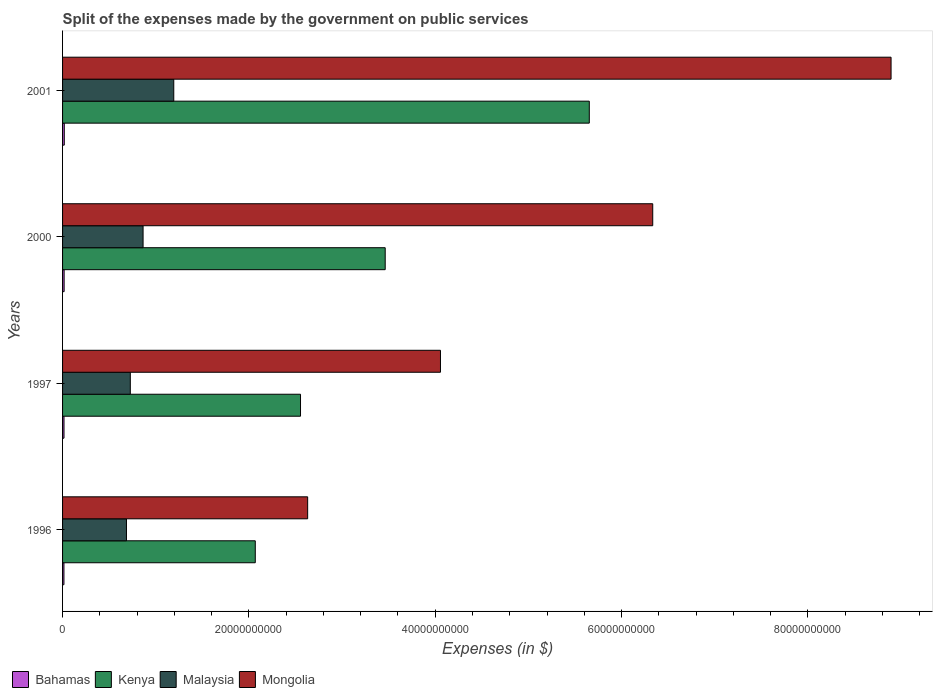How many different coloured bars are there?
Offer a terse response. 4. How many groups of bars are there?
Ensure brevity in your answer.  4. Are the number of bars per tick equal to the number of legend labels?
Your response must be concise. Yes. How many bars are there on the 3rd tick from the bottom?
Your response must be concise. 4. In how many cases, is the number of bars for a given year not equal to the number of legend labels?
Offer a very short reply. 0. What is the expenses made by the government on public services in Mongolia in 1997?
Provide a succinct answer. 4.06e+1. Across all years, what is the maximum expenses made by the government on public services in Bahamas?
Offer a terse response. 1.85e+08. Across all years, what is the minimum expenses made by the government on public services in Bahamas?
Your response must be concise. 1.47e+08. In which year was the expenses made by the government on public services in Bahamas maximum?
Keep it short and to the point. 2001. In which year was the expenses made by the government on public services in Mongolia minimum?
Provide a succinct answer. 1996. What is the total expenses made by the government on public services in Kenya in the graph?
Offer a terse response. 1.37e+11. What is the difference between the expenses made by the government on public services in Kenya in 1996 and that in 2001?
Provide a succinct answer. -3.59e+1. What is the difference between the expenses made by the government on public services in Kenya in 2000 and the expenses made by the government on public services in Mongolia in 1997?
Your answer should be very brief. -5.93e+09. What is the average expenses made by the government on public services in Bahamas per year?
Provide a short and direct response. 1.63e+08. In the year 2001, what is the difference between the expenses made by the government on public services in Bahamas and expenses made by the government on public services in Mongolia?
Provide a short and direct response. -8.87e+1. In how many years, is the expenses made by the government on public services in Malaysia greater than 84000000000 $?
Offer a very short reply. 0. What is the ratio of the expenses made by the government on public services in Malaysia in 1997 to that in 2000?
Provide a short and direct response. 0.84. Is the difference between the expenses made by the government on public services in Bahamas in 1997 and 2000 greater than the difference between the expenses made by the government on public services in Mongolia in 1997 and 2000?
Keep it short and to the point. Yes. What is the difference between the highest and the second highest expenses made by the government on public services in Mongolia?
Give a very brief answer. 2.56e+1. What is the difference between the highest and the lowest expenses made by the government on public services in Mongolia?
Give a very brief answer. 6.26e+1. Is the sum of the expenses made by the government on public services in Bahamas in 2000 and 2001 greater than the maximum expenses made by the government on public services in Malaysia across all years?
Your response must be concise. No. What does the 2nd bar from the top in 2001 represents?
Give a very brief answer. Malaysia. What does the 2nd bar from the bottom in 2000 represents?
Provide a short and direct response. Kenya. Are all the bars in the graph horizontal?
Your response must be concise. Yes. How many years are there in the graph?
Your answer should be very brief. 4. What is the difference between two consecutive major ticks on the X-axis?
Provide a succinct answer. 2.00e+1. Does the graph contain grids?
Make the answer very short. No. How are the legend labels stacked?
Offer a very short reply. Horizontal. What is the title of the graph?
Keep it short and to the point. Split of the expenses made by the government on public services. Does "Malawi" appear as one of the legend labels in the graph?
Your answer should be compact. No. What is the label or title of the X-axis?
Make the answer very short. Expenses (in $). What is the Expenses (in $) of Bahamas in 1996?
Your response must be concise. 1.47e+08. What is the Expenses (in $) in Kenya in 1996?
Your answer should be very brief. 2.07e+1. What is the Expenses (in $) in Malaysia in 1996?
Offer a terse response. 6.86e+09. What is the Expenses (in $) of Mongolia in 1996?
Ensure brevity in your answer.  2.63e+1. What is the Expenses (in $) of Bahamas in 1997?
Give a very brief answer. 1.54e+08. What is the Expenses (in $) of Kenya in 1997?
Make the answer very short. 2.55e+1. What is the Expenses (in $) of Malaysia in 1997?
Your response must be concise. 7.27e+09. What is the Expenses (in $) in Mongolia in 1997?
Your answer should be very brief. 4.06e+1. What is the Expenses (in $) of Bahamas in 2000?
Give a very brief answer. 1.68e+08. What is the Expenses (in $) in Kenya in 2000?
Make the answer very short. 3.46e+1. What is the Expenses (in $) in Malaysia in 2000?
Your answer should be very brief. 8.64e+09. What is the Expenses (in $) in Mongolia in 2000?
Keep it short and to the point. 6.34e+1. What is the Expenses (in $) of Bahamas in 2001?
Offer a very short reply. 1.85e+08. What is the Expenses (in $) in Kenya in 2001?
Your answer should be very brief. 5.65e+1. What is the Expenses (in $) of Malaysia in 2001?
Provide a short and direct response. 1.19e+1. What is the Expenses (in $) of Mongolia in 2001?
Provide a short and direct response. 8.89e+1. Across all years, what is the maximum Expenses (in $) of Bahamas?
Your answer should be very brief. 1.85e+08. Across all years, what is the maximum Expenses (in $) of Kenya?
Ensure brevity in your answer.  5.65e+1. Across all years, what is the maximum Expenses (in $) in Malaysia?
Your answer should be very brief. 1.19e+1. Across all years, what is the maximum Expenses (in $) in Mongolia?
Your answer should be very brief. 8.89e+1. Across all years, what is the minimum Expenses (in $) in Bahamas?
Offer a very short reply. 1.47e+08. Across all years, what is the minimum Expenses (in $) of Kenya?
Offer a terse response. 2.07e+1. Across all years, what is the minimum Expenses (in $) of Malaysia?
Keep it short and to the point. 6.86e+09. Across all years, what is the minimum Expenses (in $) of Mongolia?
Give a very brief answer. 2.63e+1. What is the total Expenses (in $) in Bahamas in the graph?
Keep it short and to the point. 6.54e+08. What is the total Expenses (in $) in Kenya in the graph?
Your answer should be compact. 1.37e+11. What is the total Expenses (in $) of Malaysia in the graph?
Offer a terse response. 3.47e+1. What is the total Expenses (in $) of Mongolia in the graph?
Ensure brevity in your answer.  2.19e+11. What is the difference between the Expenses (in $) of Bahamas in 1996 and that in 1997?
Offer a very short reply. -7.70e+06. What is the difference between the Expenses (in $) in Kenya in 1996 and that in 1997?
Give a very brief answer. -4.86e+09. What is the difference between the Expenses (in $) of Malaysia in 1996 and that in 1997?
Provide a succinct answer. -4.12e+08. What is the difference between the Expenses (in $) in Mongolia in 1996 and that in 1997?
Offer a very short reply. -1.43e+1. What is the difference between the Expenses (in $) of Bahamas in 1996 and that in 2000?
Provide a short and direct response. -2.09e+07. What is the difference between the Expenses (in $) in Kenya in 1996 and that in 2000?
Provide a short and direct response. -1.39e+1. What is the difference between the Expenses (in $) of Malaysia in 1996 and that in 2000?
Your answer should be very brief. -1.78e+09. What is the difference between the Expenses (in $) in Mongolia in 1996 and that in 2000?
Make the answer very short. -3.70e+1. What is the difference between the Expenses (in $) in Bahamas in 1996 and that in 2001?
Offer a terse response. -3.81e+07. What is the difference between the Expenses (in $) of Kenya in 1996 and that in 2001?
Offer a terse response. -3.59e+1. What is the difference between the Expenses (in $) of Malaysia in 1996 and that in 2001?
Provide a short and direct response. -5.08e+09. What is the difference between the Expenses (in $) in Mongolia in 1996 and that in 2001?
Offer a very short reply. -6.26e+1. What is the difference between the Expenses (in $) of Bahamas in 1997 and that in 2000?
Provide a short and direct response. -1.32e+07. What is the difference between the Expenses (in $) in Kenya in 1997 and that in 2000?
Your response must be concise. -9.09e+09. What is the difference between the Expenses (in $) in Malaysia in 1997 and that in 2000?
Your answer should be compact. -1.37e+09. What is the difference between the Expenses (in $) of Mongolia in 1997 and that in 2000?
Keep it short and to the point. -2.28e+1. What is the difference between the Expenses (in $) of Bahamas in 1997 and that in 2001?
Keep it short and to the point. -3.04e+07. What is the difference between the Expenses (in $) in Kenya in 1997 and that in 2001?
Offer a terse response. -3.10e+1. What is the difference between the Expenses (in $) of Malaysia in 1997 and that in 2001?
Provide a succinct answer. -4.66e+09. What is the difference between the Expenses (in $) of Mongolia in 1997 and that in 2001?
Give a very brief answer. -4.84e+1. What is the difference between the Expenses (in $) in Bahamas in 2000 and that in 2001?
Provide a short and direct response. -1.72e+07. What is the difference between the Expenses (in $) in Kenya in 2000 and that in 2001?
Provide a succinct answer. -2.19e+1. What is the difference between the Expenses (in $) in Malaysia in 2000 and that in 2001?
Your answer should be very brief. -3.29e+09. What is the difference between the Expenses (in $) of Mongolia in 2000 and that in 2001?
Offer a very short reply. -2.56e+1. What is the difference between the Expenses (in $) in Bahamas in 1996 and the Expenses (in $) in Kenya in 1997?
Offer a very short reply. -2.54e+1. What is the difference between the Expenses (in $) of Bahamas in 1996 and the Expenses (in $) of Malaysia in 1997?
Offer a terse response. -7.13e+09. What is the difference between the Expenses (in $) of Bahamas in 1996 and the Expenses (in $) of Mongolia in 1997?
Keep it short and to the point. -4.04e+1. What is the difference between the Expenses (in $) in Kenya in 1996 and the Expenses (in $) in Malaysia in 1997?
Your response must be concise. 1.34e+1. What is the difference between the Expenses (in $) in Kenya in 1996 and the Expenses (in $) in Mongolia in 1997?
Provide a succinct answer. -1.99e+1. What is the difference between the Expenses (in $) of Malaysia in 1996 and the Expenses (in $) of Mongolia in 1997?
Your response must be concise. -3.37e+1. What is the difference between the Expenses (in $) in Bahamas in 1996 and the Expenses (in $) in Kenya in 2000?
Your response must be concise. -3.45e+1. What is the difference between the Expenses (in $) of Bahamas in 1996 and the Expenses (in $) of Malaysia in 2000?
Your answer should be compact. -8.50e+09. What is the difference between the Expenses (in $) of Bahamas in 1996 and the Expenses (in $) of Mongolia in 2000?
Provide a short and direct response. -6.32e+1. What is the difference between the Expenses (in $) in Kenya in 1996 and the Expenses (in $) in Malaysia in 2000?
Your response must be concise. 1.20e+1. What is the difference between the Expenses (in $) in Kenya in 1996 and the Expenses (in $) in Mongolia in 2000?
Your answer should be very brief. -4.27e+1. What is the difference between the Expenses (in $) in Malaysia in 1996 and the Expenses (in $) in Mongolia in 2000?
Keep it short and to the point. -5.65e+1. What is the difference between the Expenses (in $) of Bahamas in 1996 and the Expenses (in $) of Kenya in 2001?
Your answer should be very brief. -5.64e+1. What is the difference between the Expenses (in $) in Bahamas in 1996 and the Expenses (in $) in Malaysia in 2001?
Provide a short and direct response. -1.18e+1. What is the difference between the Expenses (in $) of Bahamas in 1996 and the Expenses (in $) of Mongolia in 2001?
Provide a short and direct response. -8.88e+1. What is the difference between the Expenses (in $) in Kenya in 1996 and the Expenses (in $) in Malaysia in 2001?
Your response must be concise. 8.75e+09. What is the difference between the Expenses (in $) of Kenya in 1996 and the Expenses (in $) of Mongolia in 2001?
Your response must be concise. -6.82e+1. What is the difference between the Expenses (in $) in Malaysia in 1996 and the Expenses (in $) in Mongolia in 2001?
Give a very brief answer. -8.21e+1. What is the difference between the Expenses (in $) of Bahamas in 1997 and the Expenses (in $) of Kenya in 2000?
Give a very brief answer. -3.45e+1. What is the difference between the Expenses (in $) of Bahamas in 1997 and the Expenses (in $) of Malaysia in 2000?
Make the answer very short. -8.49e+09. What is the difference between the Expenses (in $) in Bahamas in 1997 and the Expenses (in $) in Mongolia in 2000?
Ensure brevity in your answer.  -6.32e+1. What is the difference between the Expenses (in $) of Kenya in 1997 and the Expenses (in $) of Malaysia in 2000?
Give a very brief answer. 1.69e+1. What is the difference between the Expenses (in $) in Kenya in 1997 and the Expenses (in $) in Mongolia in 2000?
Ensure brevity in your answer.  -3.78e+1. What is the difference between the Expenses (in $) of Malaysia in 1997 and the Expenses (in $) of Mongolia in 2000?
Offer a very short reply. -5.61e+1. What is the difference between the Expenses (in $) in Bahamas in 1997 and the Expenses (in $) in Kenya in 2001?
Your answer should be compact. -5.64e+1. What is the difference between the Expenses (in $) of Bahamas in 1997 and the Expenses (in $) of Malaysia in 2001?
Give a very brief answer. -1.18e+1. What is the difference between the Expenses (in $) of Bahamas in 1997 and the Expenses (in $) of Mongolia in 2001?
Your response must be concise. -8.88e+1. What is the difference between the Expenses (in $) in Kenya in 1997 and the Expenses (in $) in Malaysia in 2001?
Provide a succinct answer. 1.36e+1. What is the difference between the Expenses (in $) in Kenya in 1997 and the Expenses (in $) in Mongolia in 2001?
Ensure brevity in your answer.  -6.34e+1. What is the difference between the Expenses (in $) of Malaysia in 1997 and the Expenses (in $) of Mongolia in 2001?
Ensure brevity in your answer.  -8.17e+1. What is the difference between the Expenses (in $) in Bahamas in 2000 and the Expenses (in $) in Kenya in 2001?
Your answer should be very brief. -5.64e+1. What is the difference between the Expenses (in $) of Bahamas in 2000 and the Expenses (in $) of Malaysia in 2001?
Your answer should be compact. -1.18e+1. What is the difference between the Expenses (in $) in Bahamas in 2000 and the Expenses (in $) in Mongolia in 2001?
Your answer should be very brief. -8.88e+1. What is the difference between the Expenses (in $) in Kenya in 2000 and the Expenses (in $) in Malaysia in 2001?
Ensure brevity in your answer.  2.27e+1. What is the difference between the Expenses (in $) in Kenya in 2000 and the Expenses (in $) in Mongolia in 2001?
Offer a very short reply. -5.43e+1. What is the difference between the Expenses (in $) in Malaysia in 2000 and the Expenses (in $) in Mongolia in 2001?
Provide a short and direct response. -8.03e+1. What is the average Expenses (in $) of Bahamas per year?
Your response must be concise. 1.63e+08. What is the average Expenses (in $) in Kenya per year?
Your answer should be very brief. 3.44e+1. What is the average Expenses (in $) in Malaysia per year?
Your answer should be compact. 8.68e+09. What is the average Expenses (in $) of Mongolia per year?
Make the answer very short. 5.48e+1. In the year 1996, what is the difference between the Expenses (in $) of Bahamas and Expenses (in $) of Kenya?
Your response must be concise. -2.05e+1. In the year 1996, what is the difference between the Expenses (in $) in Bahamas and Expenses (in $) in Malaysia?
Keep it short and to the point. -6.71e+09. In the year 1996, what is the difference between the Expenses (in $) in Bahamas and Expenses (in $) in Mongolia?
Your answer should be compact. -2.62e+1. In the year 1996, what is the difference between the Expenses (in $) in Kenya and Expenses (in $) in Malaysia?
Offer a terse response. 1.38e+1. In the year 1996, what is the difference between the Expenses (in $) of Kenya and Expenses (in $) of Mongolia?
Make the answer very short. -5.62e+09. In the year 1996, what is the difference between the Expenses (in $) in Malaysia and Expenses (in $) in Mongolia?
Provide a short and direct response. -1.94e+1. In the year 1997, what is the difference between the Expenses (in $) in Bahamas and Expenses (in $) in Kenya?
Your response must be concise. -2.54e+1. In the year 1997, what is the difference between the Expenses (in $) in Bahamas and Expenses (in $) in Malaysia?
Provide a short and direct response. -7.12e+09. In the year 1997, what is the difference between the Expenses (in $) of Bahamas and Expenses (in $) of Mongolia?
Your response must be concise. -4.04e+1. In the year 1997, what is the difference between the Expenses (in $) in Kenya and Expenses (in $) in Malaysia?
Provide a short and direct response. 1.83e+1. In the year 1997, what is the difference between the Expenses (in $) of Kenya and Expenses (in $) of Mongolia?
Make the answer very short. -1.50e+1. In the year 1997, what is the difference between the Expenses (in $) of Malaysia and Expenses (in $) of Mongolia?
Provide a succinct answer. -3.33e+1. In the year 2000, what is the difference between the Expenses (in $) of Bahamas and Expenses (in $) of Kenya?
Ensure brevity in your answer.  -3.45e+1. In the year 2000, what is the difference between the Expenses (in $) of Bahamas and Expenses (in $) of Malaysia?
Your response must be concise. -8.47e+09. In the year 2000, what is the difference between the Expenses (in $) in Bahamas and Expenses (in $) in Mongolia?
Your answer should be very brief. -6.32e+1. In the year 2000, what is the difference between the Expenses (in $) of Kenya and Expenses (in $) of Malaysia?
Your response must be concise. 2.60e+1. In the year 2000, what is the difference between the Expenses (in $) of Kenya and Expenses (in $) of Mongolia?
Make the answer very short. -2.87e+1. In the year 2000, what is the difference between the Expenses (in $) of Malaysia and Expenses (in $) of Mongolia?
Keep it short and to the point. -5.47e+1. In the year 2001, what is the difference between the Expenses (in $) of Bahamas and Expenses (in $) of Kenya?
Make the answer very short. -5.64e+1. In the year 2001, what is the difference between the Expenses (in $) in Bahamas and Expenses (in $) in Malaysia?
Make the answer very short. -1.18e+1. In the year 2001, what is the difference between the Expenses (in $) in Bahamas and Expenses (in $) in Mongolia?
Provide a succinct answer. -8.87e+1. In the year 2001, what is the difference between the Expenses (in $) in Kenya and Expenses (in $) in Malaysia?
Make the answer very short. 4.46e+1. In the year 2001, what is the difference between the Expenses (in $) in Kenya and Expenses (in $) in Mongolia?
Keep it short and to the point. -3.24e+1. In the year 2001, what is the difference between the Expenses (in $) of Malaysia and Expenses (in $) of Mongolia?
Give a very brief answer. -7.70e+1. What is the ratio of the Expenses (in $) of Bahamas in 1996 to that in 1997?
Provide a short and direct response. 0.95. What is the ratio of the Expenses (in $) in Kenya in 1996 to that in 1997?
Offer a very short reply. 0.81. What is the ratio of the Expenses (in $) in Malaysia in 1996 to that in 1997?
Your response must be concise. 0.94. What is the ratio of the Expenses (in $) in Mongolia in 1996 to that in 1997?
Your response must be concise. 0.65. What is the ratio of the Expenses (in $) in Bahamas in 1996 to that in 2000?
Provide a short and direct response. 0.88. What is the ratio of the Expenses (in $) of Kenya in 1996 to that in 2000?
Make the answer very short. 0.6. What is the ratio of the Expenses (in $) of Malaysia in 1996 to that in 2000?
Your response must be concise. 0.79. What is the ratio of the Expenses (in $) in Mongolia in 1996 to that in 2000?
Make the answer very short. 0.42. What is the ratio of the Expenses (in $) of Bahamas in 1996 to that in 2001?
Ensure brevity in your answer.  0.79. What is the ratio of the Expenses (in $) of Kenya in 1996 to that in 2001?
Provide a short and direct response. 0.37. What is the ratio of the Expenses (in $) in Malaysia in 1996 to that in 2001?
Offer a terse response. 0.57. What is the ratio of the Expenses (in $) of Mongolia in 1996 to that in 2001?
Ensure brevity in your answer.  0.3. What is the ratio of the Expenses (in $) of Bahamas in 1997 to that in 2000?
Keep it short and to the point. 0.92. What is the ratio of the Expenses (in $) in Kenya in 1997 to that in 2000?
Offer a terse response. 0.74. What is the ratio of the Expenses (in $) in Malaysia in 1997 to that in 2000?
Your response must be concise. 0.84. What is the ratio of the Expenses (in $) of Mongolia in 1997 to that in 2000?
Offer a very short reply. 0.64. What is the ratio of the Expenses (in $) of Bahamas in 1997 to that in 2001?
Provide a succinct answer. 0.84. What is the ratio of the Expenses (in $) of Kenya in 1997 to that in 2001?
Ensure brevity in your answer.  0.45. What is the ratio of the Expenses (in $) of Malaysia in 1997 to that in 2001?
Your answer should be compact. 0.61. What is the ratio of the Expenses (in $) of Mongolia in 1997 to that in 2001?
Give a very brief answer. 0.46. What is the ratio of the Expenses (in $) of Bahamas in 2000 to that in 2001?
Make the answer very short. 0.91. What is the ratio of the Expenses (in $) in Kenya in 2000 to that in 2001?
Make the answer very short. 0.61. What is the ratio of the Expenses (in $) in Malaysia in 2000 to that in 2001?
Give a very brief answer. 0.72. What is the ratio of the Expenses (in $) in Mongolia in 2000 to that in 2001?
Offer a terse response. 0.71. What is the difference between the highest and the second highest Expenses (in $) in Bahamas?
Provide a short and direct response. 1.72e+07. What is the difference between the highest and the second highest Expenses (in $) of Kenya?
Give a very brief answer. 2.19e+1. What is the difference between the highest and the second highest Expenses (in $) of Malaysia?
Your answer should be compact. 3.29e+09. What is the difference between the highest and the second highest Expenses (in $) of Mongolia?
Your answer should be very brief. 2.56e+1. What is the difference between the highest and the lowest Expenses (in $) of Bahamas?
Offer a terse response. 3.81e+07. What is the difference between the highest and the lowest Expenses (in $) of Kenya?
Provide a succinct answer. 3.59e+1. What is the difference between the highest and the lowest Expenses (in $) in Malaysia?
Your answer should be very brief. 5.08e+09. What is the difference between the highest and the lowest Expenses (in $) of Mongolia?
Your response must be concise. 6.26e+1. 